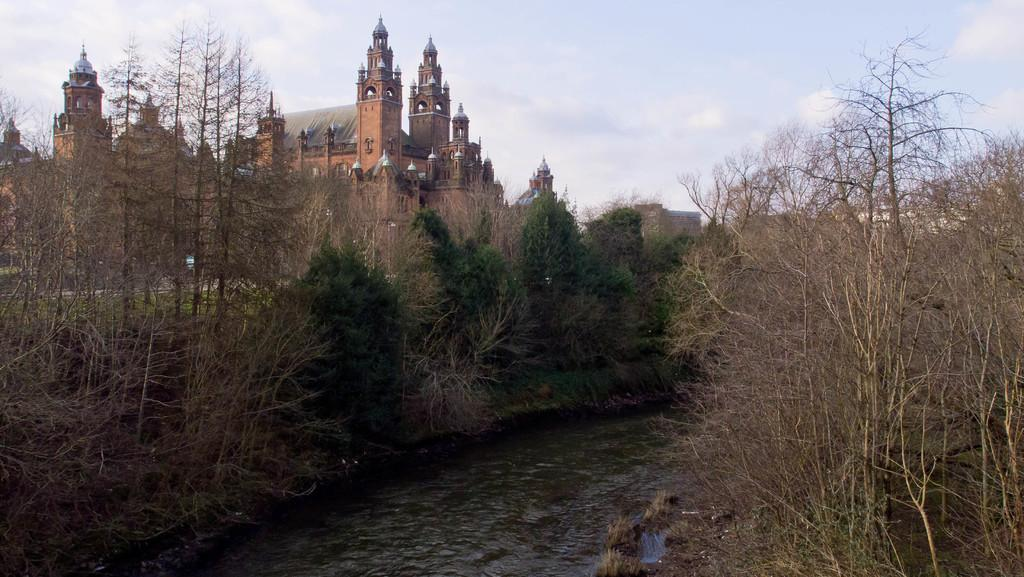What can be seen in the image that is related to water? There is water visible in the image. What type of vegetation is present in the image? There are plants and trees in the image. What kind of structure can be seen in the background of the image? There is a building in the background of the image that resembles a palace. What is visible at the top of the image? The sky is visible at the top of the image. What type of amusement can be seen in the image? There is no amusement present in the image; it features water, plants, trees, and a building. What color is the quince in the image? There is no quince present in the image. 